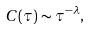Convert formula to latex. <formula><loc_0><loc_0><loc_500><loc_500>C ( \tau ) \sim \tau ^ { - \lambda } ,</formula> 